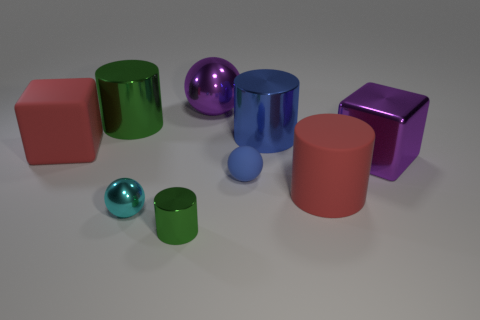How many purple spheres have the same material as the large red cube?
Provide a succinct answer. 0. Is there a green metallic cylinder that is behind the tiny sphere in front of the big matte object in front of the large purple block?
Give a very brief answer. Yes. There is a blue object that is the same material as the red cylinder; what is its shape?
Offer a very short reply. Sphere. Are there more blue matte objects than green metal things?
Your answer should be very brief. No. There is a tiny green object; does it have the same shape as the big red object in front of the matte ball?
Your answer should be very brief. Yes. What is the large sphere made of?
Provide a succinct answer. Metal. What color is the ball that is behind the green object left of the ball that is in front of the tiny blue object?
Ensure brevity in your answer.  Purple. There is a large red thing that is the same shape as the large green metal thing; what is its material?
Provide a short and direct response. Rubber. What number of purple shiny balls are the same size as the metallic cube?
Give a very brief answer. 1. How many blue rubber cylinders are there?
Offer a very short reply. 0. 